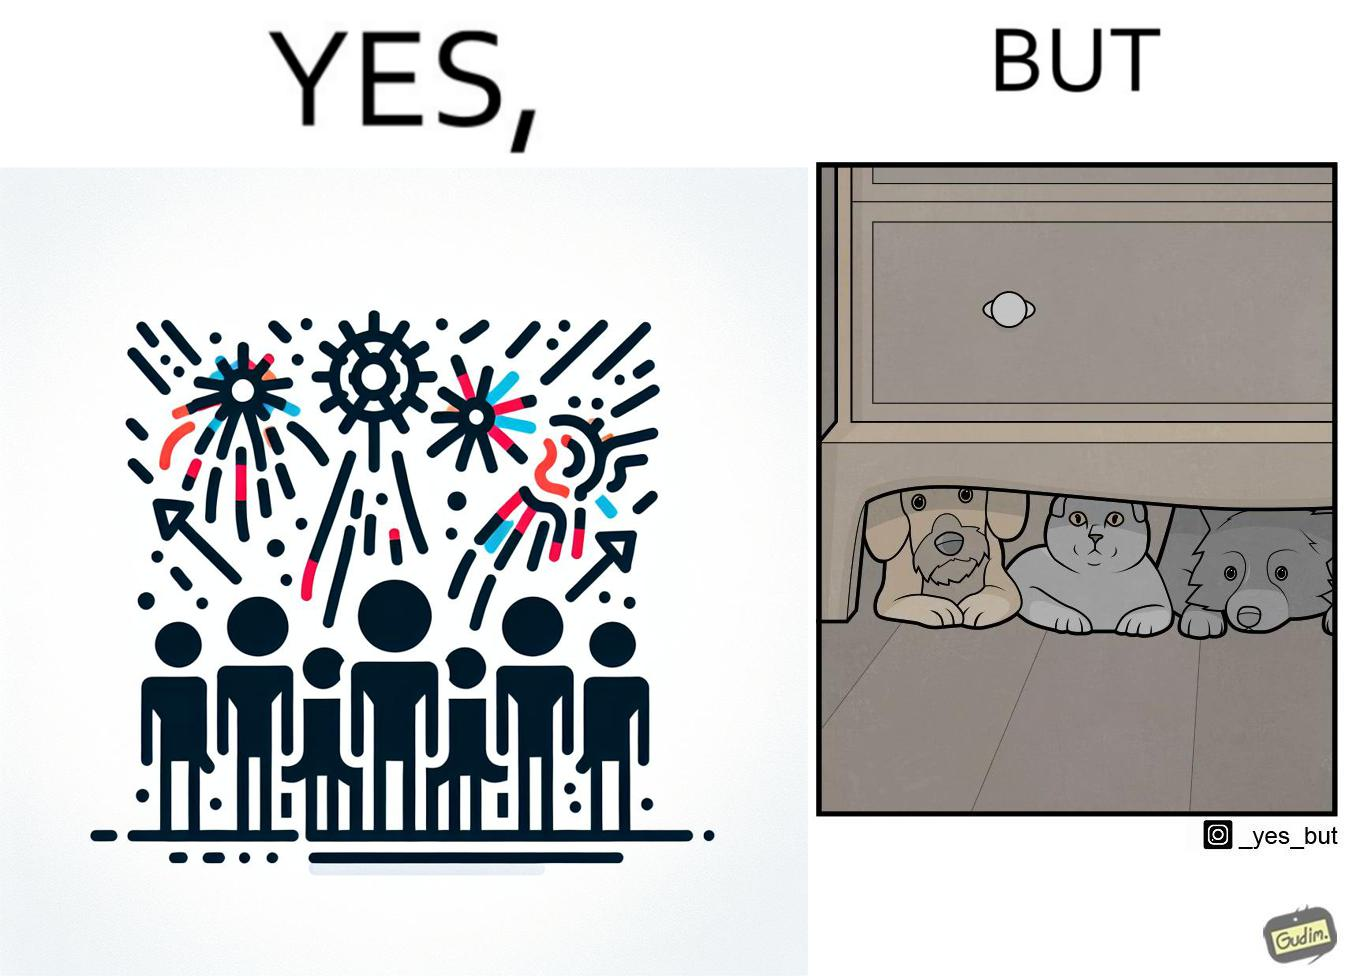Would you classify this image as satirical? Yes, this image is satirical. 